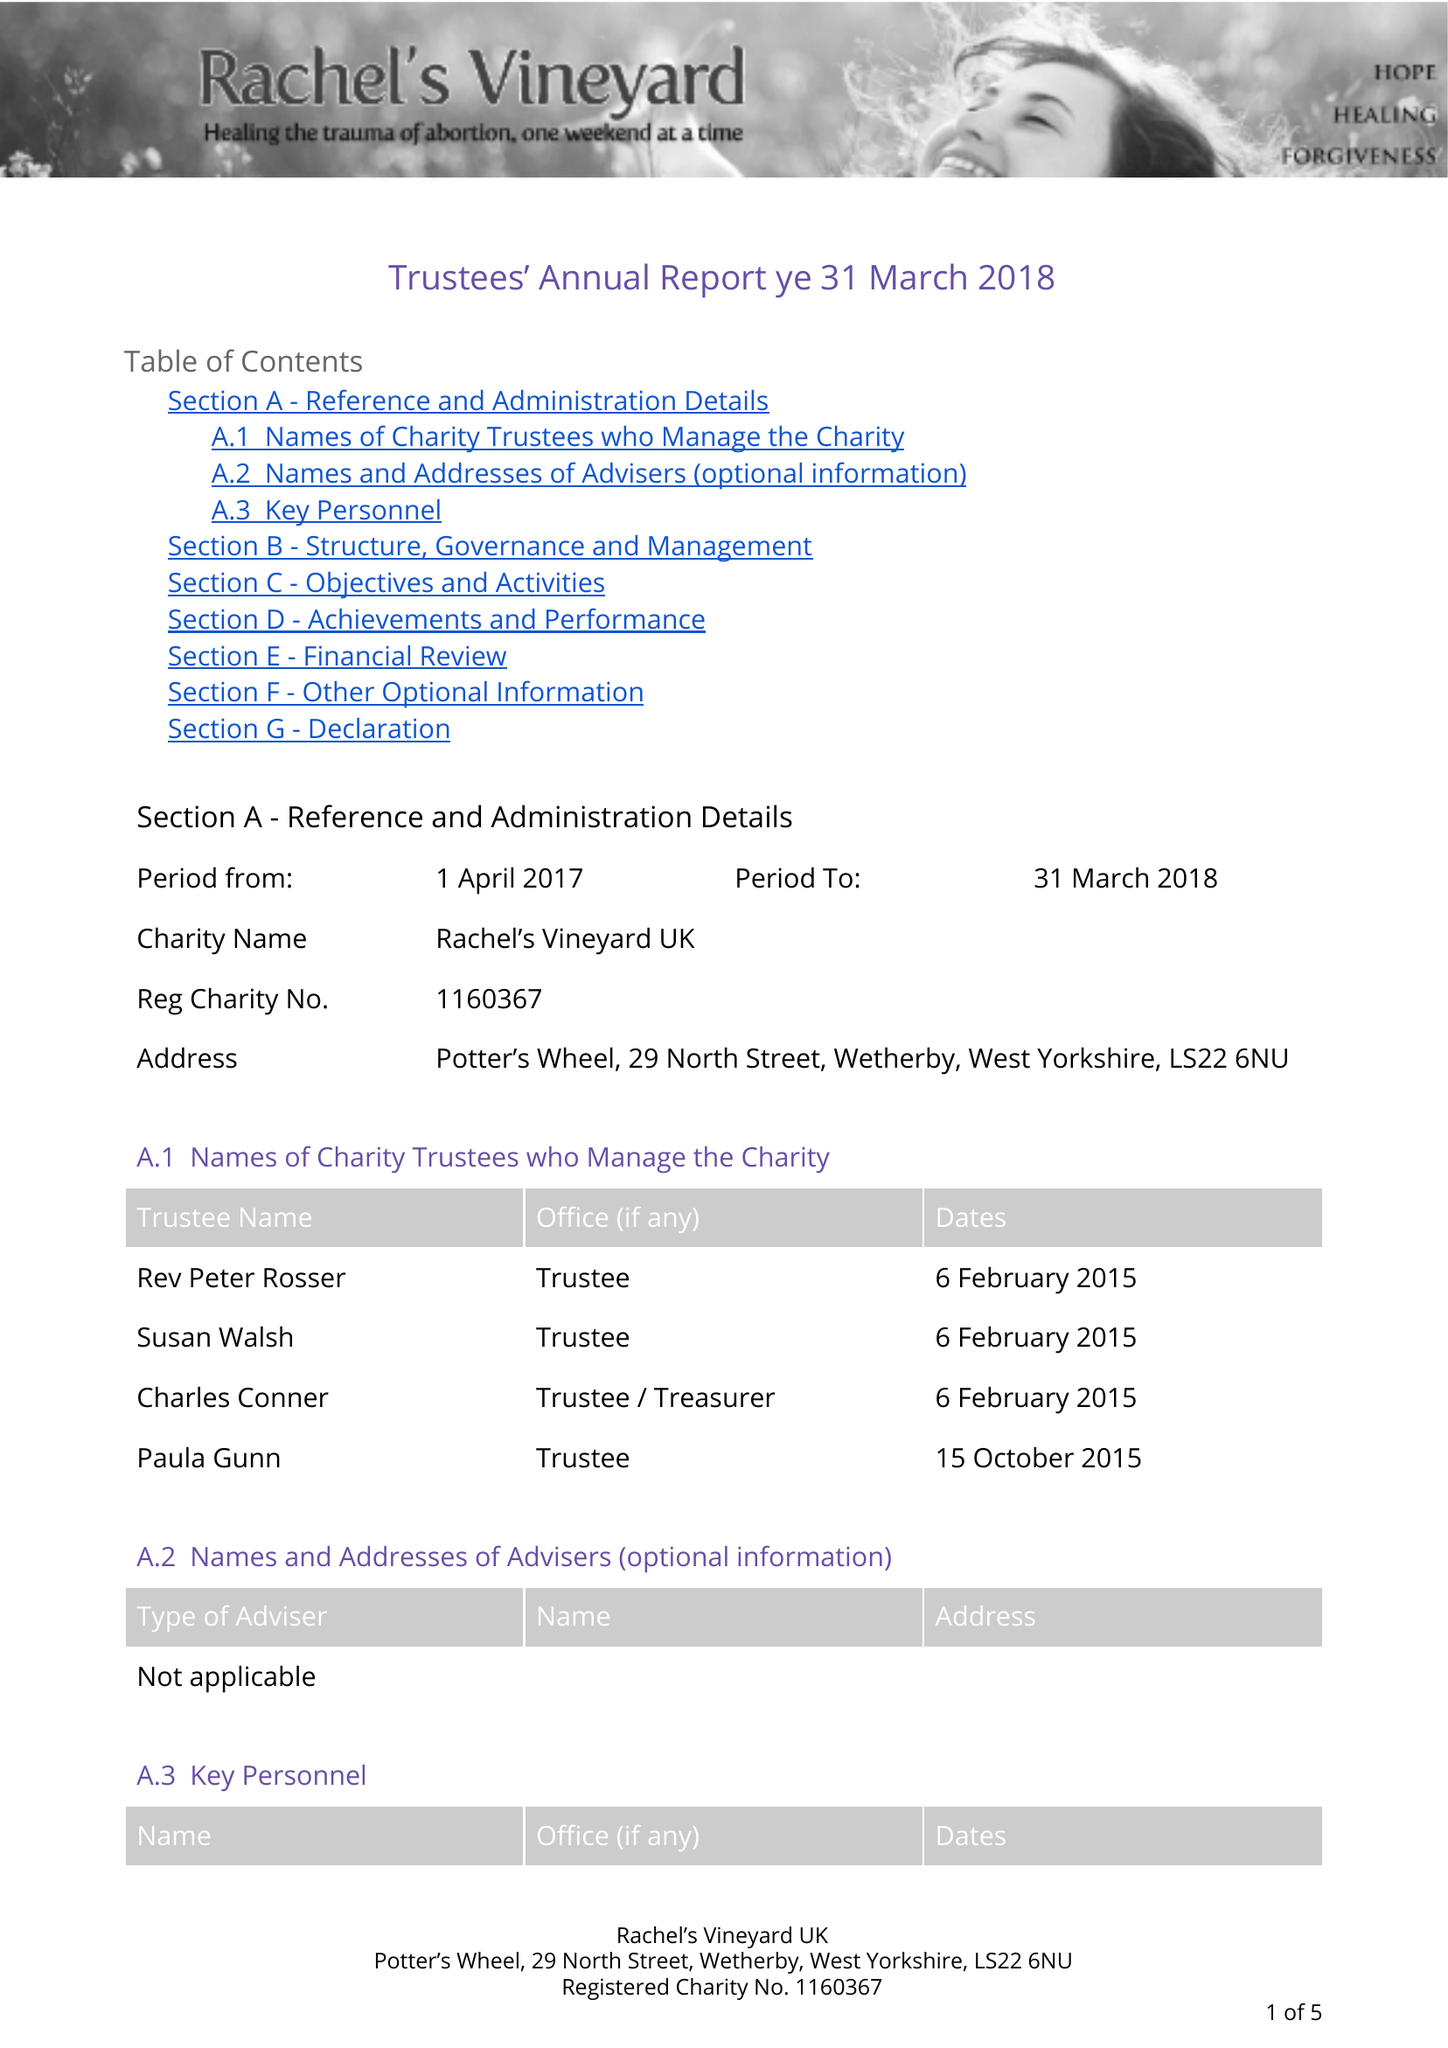What is the value for the charity_name?
Answer the question using a single word or phrase. Rachel's Vineyard Uk 